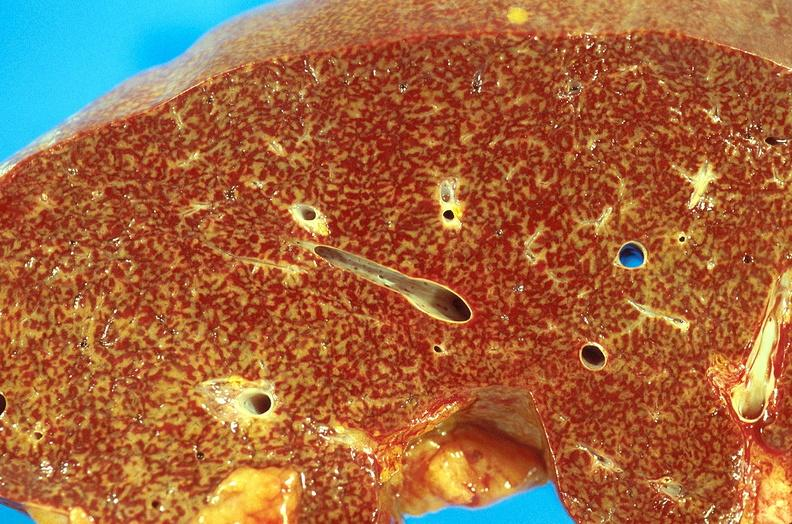does hemorrhagic corpus luteum show chronic passive congestion, liver?
Answer the question using a single word or phrase. No 